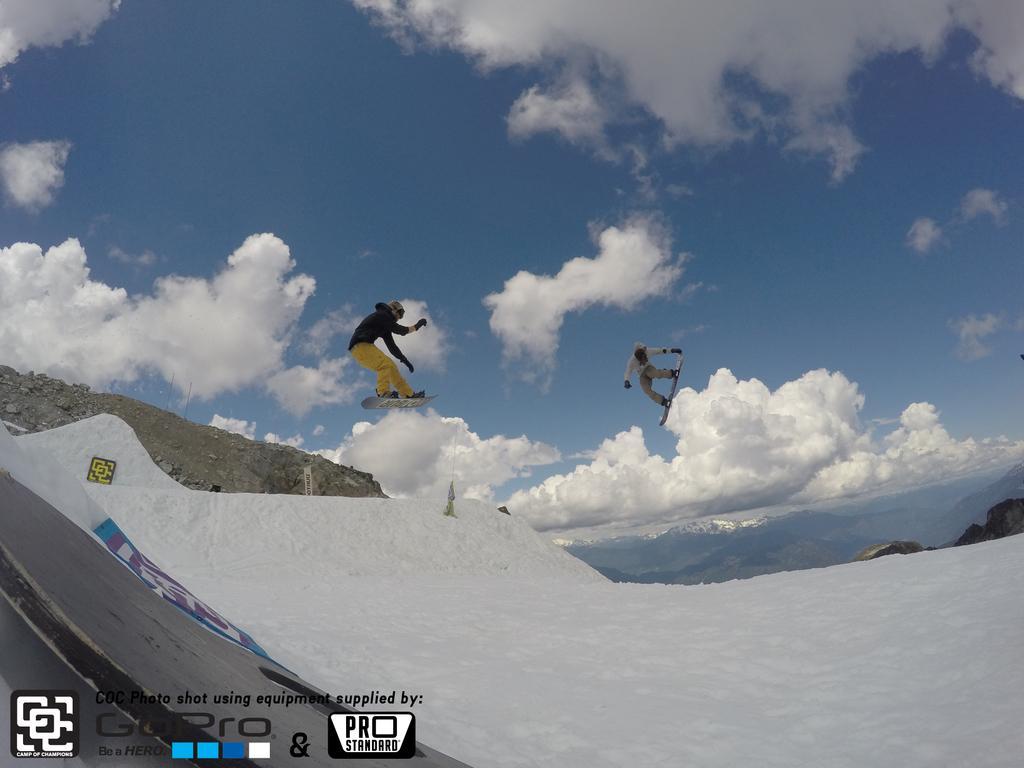How would you summarize this image in a sentence or two? In the foreground of this picture, there are two men skating and they are in air. In the background, there is the sky and the cloud. 